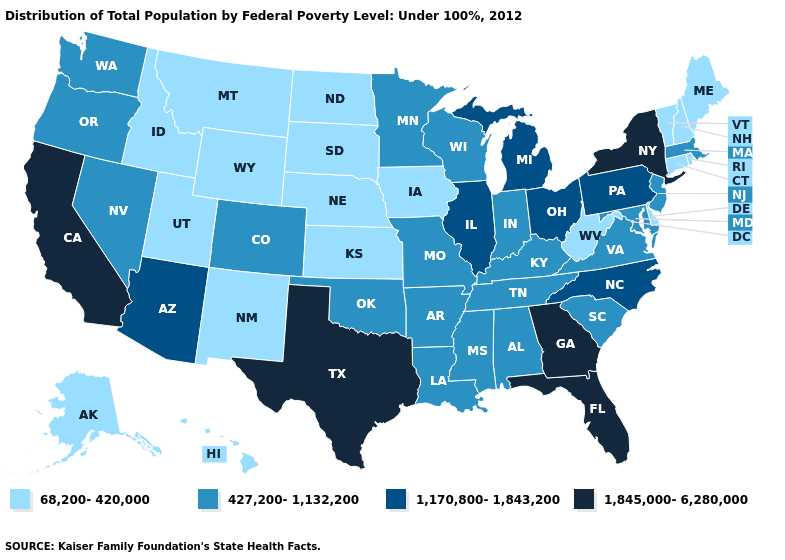Does Indiana have the highest value in the MidWest?
Give a very brief answer. No. Which states hav the highest value in the West?
Give a very brief answer. California. Does Vermont have the highest value in the Northeast?
Be succinct. No. What is the highest value in the MidWest ?
Quick response, please. 1,170,800-1,843,200. What is the lowest value in the USA?
Write a very short answer. 68,200-420,000. What is the value of Iowa?
Short answer required. 68,200-420,000. What is the value of Vermont?
Answer briefly. 68,200-420,000. Among the states that border Nevada , does California have the highest value?
Be succinct. Yes. Name the states that have a value in the range 1,845,000-6,280,000?
Concise answer only. California, Florida, Georgia, New York, Texas. What is the highest value in the USA?
Keep it brief. 1,845,000-6,280,000. Name the states that have a value in the range 1,845,000-6,280,000?
Write a very short answer. California, Florida, Georgia, New York, Texas. Which states have the highest value in the USA?
Keep it brief. California, Florida, Georgia, New York, Texas. What is the value of Tennessee?
Short answer required. 427,200-1,132,200. Name the states that have a value in the range 68,200-420,000?
Answer briefly. Alaska, Connecticut, Delaware, Hawaii, Idaho, Iowa, Kansas, Maine, Montana, Nebraska, New Hampshire, New Mexico, North Dakota, Rhode Island, South Dakota, Utah, Vermont, West Virginia, Wyoming. 